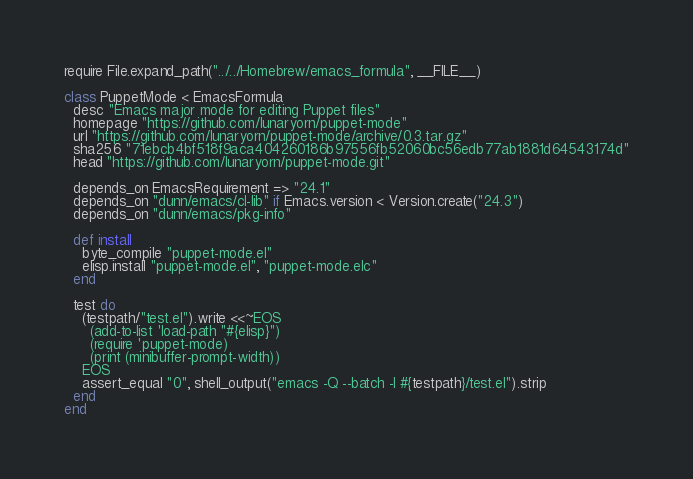<code> <loc_0><loc_0><loc_500><loc_500><_Ruby_>require File.expand_path("../../Homebrew/emacs_formula", __FILE__)

class PuppetMode < EmacsFormula
  desc "Emacs major mode for editing Puppet files"
  homepage "https://github.com/lunaryorn/puppet-mode"
  url "https://github.com/lunaryorn/puppet-mode/archive/0.3.tar.gz"
  sha256 "71ebcb4bf518f9aca404260186b97556fb52060bc56edb77ab1881d64543174d"
  head "https://github.com/lunaryorn/puppet-mode.git"

  depends_on EmacsRequirement => "24.1"
  depends_on "dunn/emacs/cl-lib" if Emacs.version < Version.create("24.3")
  depends_on "dunn/emacs/pkg-info"

  def install
    byte_compile "puppet-mode.el"
    elisp.install "puppet-mode.el", "puppet-mode.elc"
  end

  test do
    (testpath/"test.el").write <<~EOS
      (add-to-list 'load-path "#{elisp}")
      (require 'puppet-mode)
      (print (minibuffer-prompt-width))
    EOS
    assert_equal "0", shell_output("emacs -Q --batch -l #{testpath}/test.el").strip
  end
end
</code> 